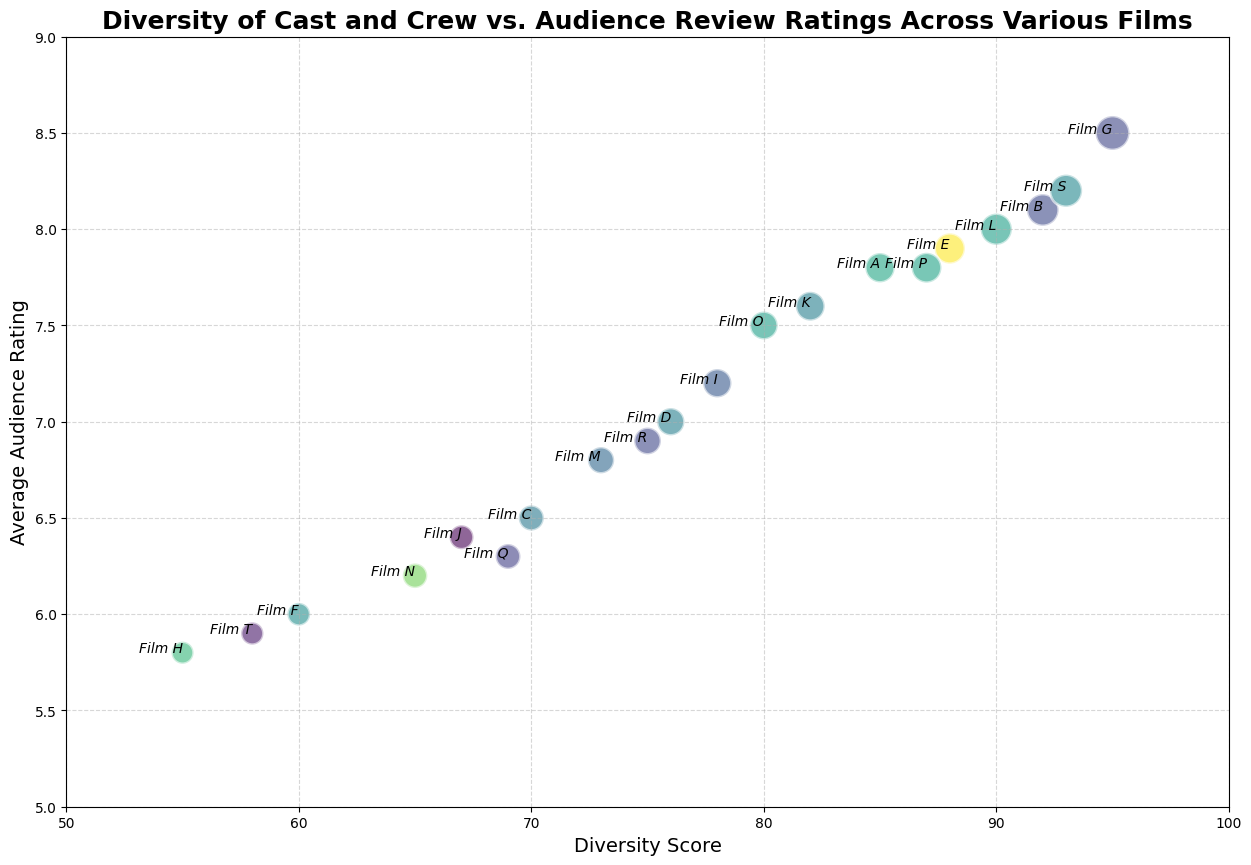How many films have a diversity score above 90? Count the number of data points where the diversity score is greater than 90. Films B, G, S have diversity scores over 90.
Answer: 3 Which film has the highest average audience rating? By examining the vertical axis (average audience rating), find the highest positioned bubble and match it with its label. Film G has the highest average audience rating of 8.5.
Answer: Film G What is the diversity score and average audience rating for Film R? Locate Film R on the chart and read its x-axis (diversity score) and y-axis (average audience rating) values. Film R has a diversity score of 75 and an average audience rating of 6.9.
Answer: 75, 6.9 Compare Films C and M: Which one has a higher diversity score and which one has a better audience rating? Locate Films C and M on the chart, note their diversity scores and average audience ratings, compare their values. Film C has a diversity score of 70 while Film M has 73 making M higher; Film C’s rating is 6.5 whereas Film M is 6.8 making M higher in both aspects.
Answer: Film M, Film M What is the correlation between diversity score and average audience rating in this chart? Observe the general trend in bubble placement from left to right on the chart. There appears to be a positive correlation as higher diversity scores generally correspond to higher audience ratings.
Answer: Positive correlation Which film has the largest number of ratings and what are its diversity score and average audience rating? Find the largest bubble on the chart, which represents the highest number of ratings, and read its x-axis and y-axis values. Film G has the largest number of ratings, a diversity score of 95, and an average audience rating of 8.5.
Answer: Film G, 95, 8.5 What is the average diversity score of films with an average audience rating above 7.0? Identify films with ratings above 7.0, sum their diversity scores, then divide by the number of those films. 86 (Film A) + 92 (Film B) + 88 (Film E) + 95 (Film G) + 78 (Film I) + 82 (Film K) + 90 (Film L) + 87 (Film P) + 93 (Film S) = 791, divided by 9 films.
Answer: 87.89 Do films with a lower diversity score (below 65) have lower audience ratings than those with higher diversity scores (above 85)? Compare the ratings of films below 65 (Films H, N, T) with those above 85 (Films B, G, S). Films H, N, T have ratings 5.8, 6.2, 5.9 respectively; while Films B, G, S have ratings 8.1, 8.5, 8.2 respectively. Films with higher diversity scores have higher ratings on average.
Answer: Yes How many films have an audience rating between 6.0 and 7.5? Count the number of data points where the audience rating lies between 6.0 and 7.5 inclusive. Films C, D, F, I, J, M, N, O, Q, R are within this range. Total is 10.
Answer: 10 